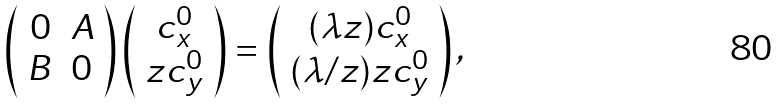Convert formula to latex. <formula><loc_0><loc_0><loc_500><loc_500>\left ( \begin{array} { c c } 0 & A \\ B & 0 \\ \end{array} \right ) \left ( \begin{array} { c } c _ { x } ^ { 0 } \\ z c _ { y } ^ { 0 } \end{array} \right ) = \left ( \begin{array} { c } ( \lambda z ) c _ { x } ^ { 0 } \\ ( \lambda / z ) z c _ { y } ^ { 0 } \end{array} \right ) ,</formula> 